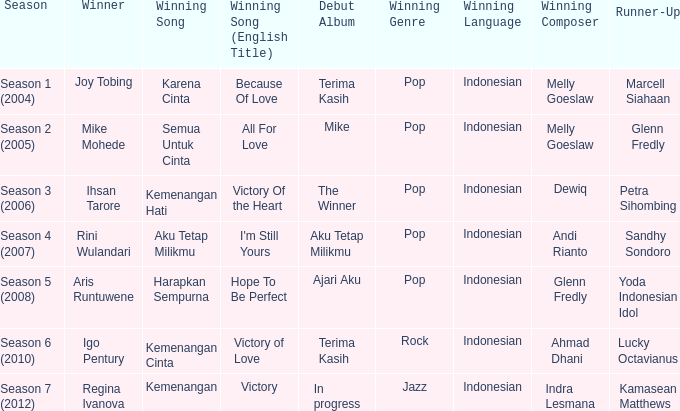Which winning song was sung by aku tetap milikmu? I'm Still Yours. 